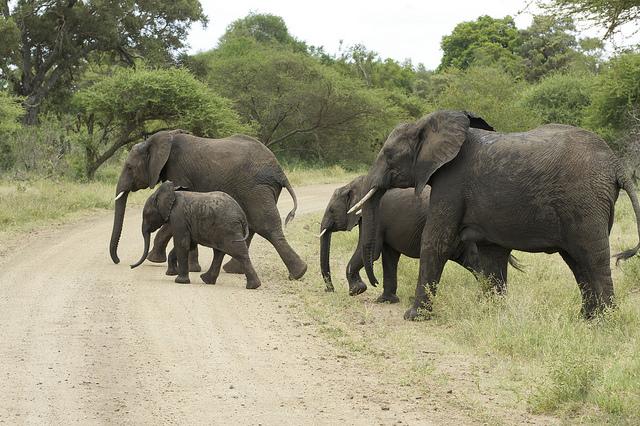Why is the immature one in the middle?
Concise answer only. Protection. Is there a place for the elephants to drink?
Keep it brief. No. Which elephant has the longer tusks?
Write a very short answer. Right. How many elephants are there?
Keep it brief. 4. Are the tails of the two elephants the same length?
Short answer required. No. What are the small elephants doing?
Write a very short answer. Walking. What are most of the elephants doing?
Give a very brief answer. Walking. Is this a family?
Concise answer only. Yes. What are the elephants crossing?
Short answer required. Road. How many animals?
Be succinct. 4. 